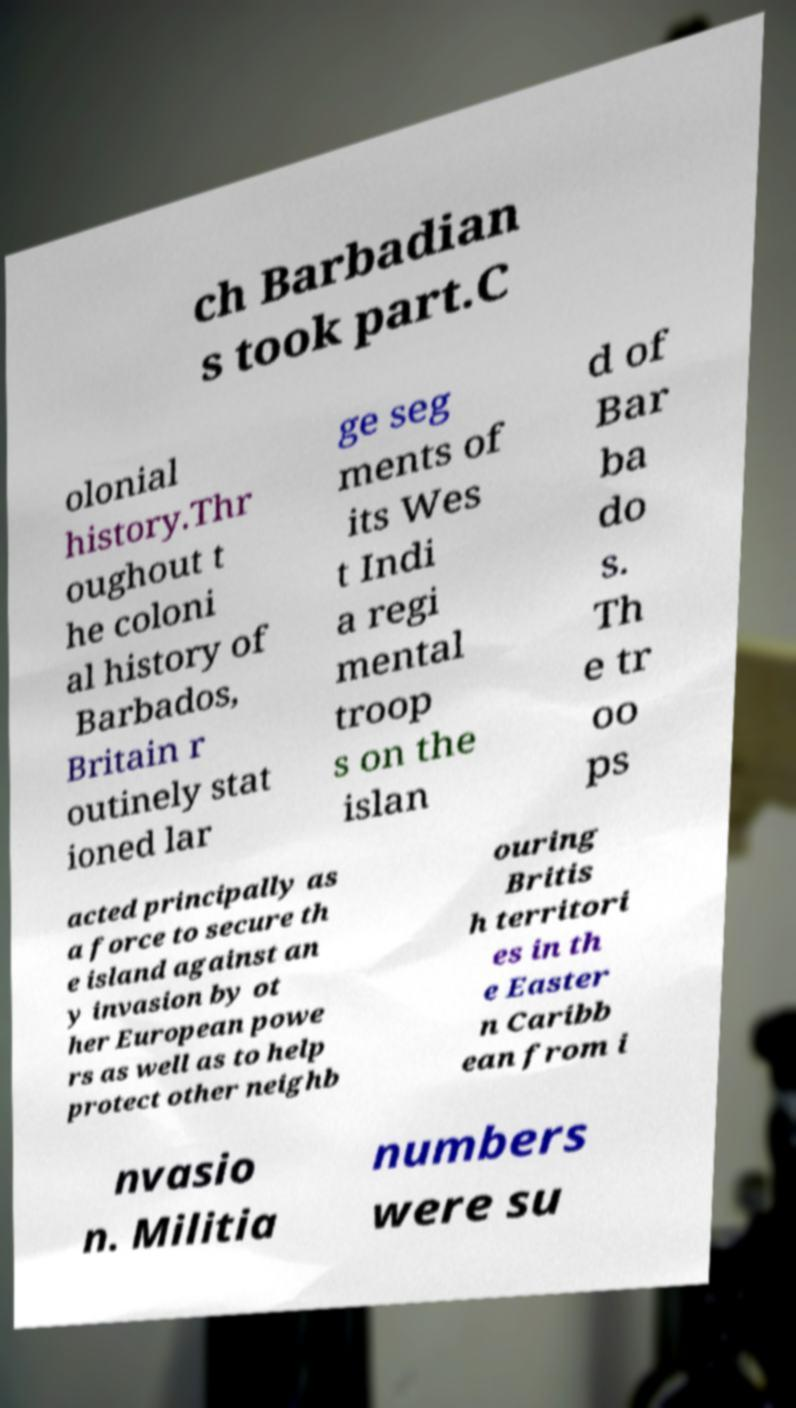Could you extract and type out the text from this image? ch Barbadian s took part.C olonial history.Thr oughout t he coloni al history of Barbados, Britain r outinely stat ioned lar ge seg ments of its Wes t Indi a regi mental troop s on the islan d of Bar ba do s. Th e tr oo ps acted principally as a force to secure th e island against an y invasion by ot her European powe rs as well as to help protect other neighb ouring Britis h territori es in th e Easter n Caribb ean from i nvasio n. Militia numbers were su 